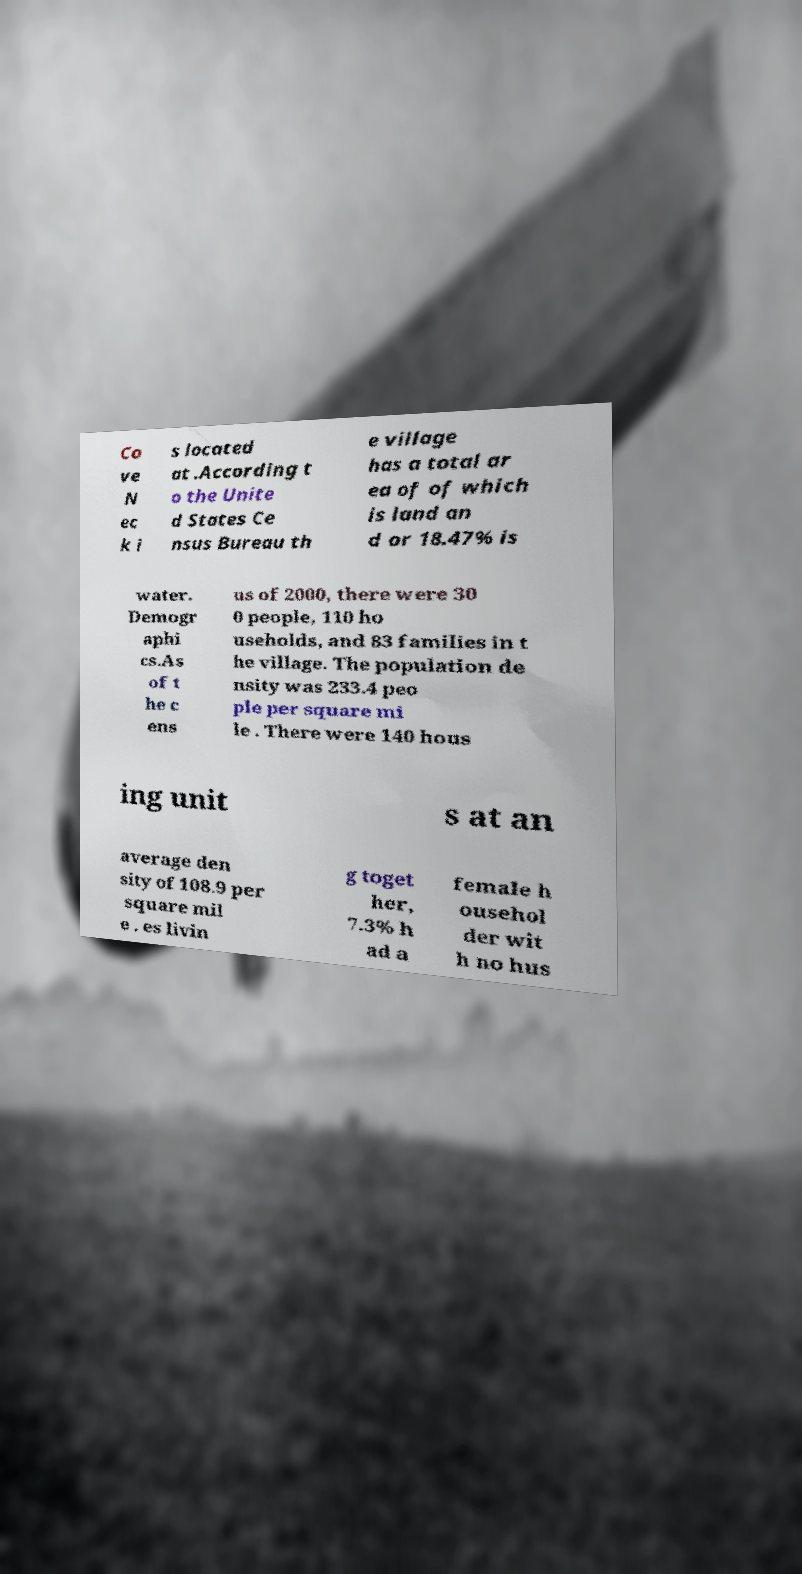For documentation purposes, I need the text within this image transcribed. Could you provide that? Co ve N ec k i s located at .According t o the Unite d States Ce nsus Bureau th e village has a total ar ea of of which is land an d or 18.47% is water. Demogr aphi cs.As of t he c ens us of 2000, there were 30 0 people, 110 ho useholds, and 83 families in t he village. The population de nsity was 233.4 peo ple per square mi le . There were 140 hous ing unit s at an average den sity of 108.9 per square mil e . es livin g toget her, 7.3% h ad a female h ousehol der wit h no hus 